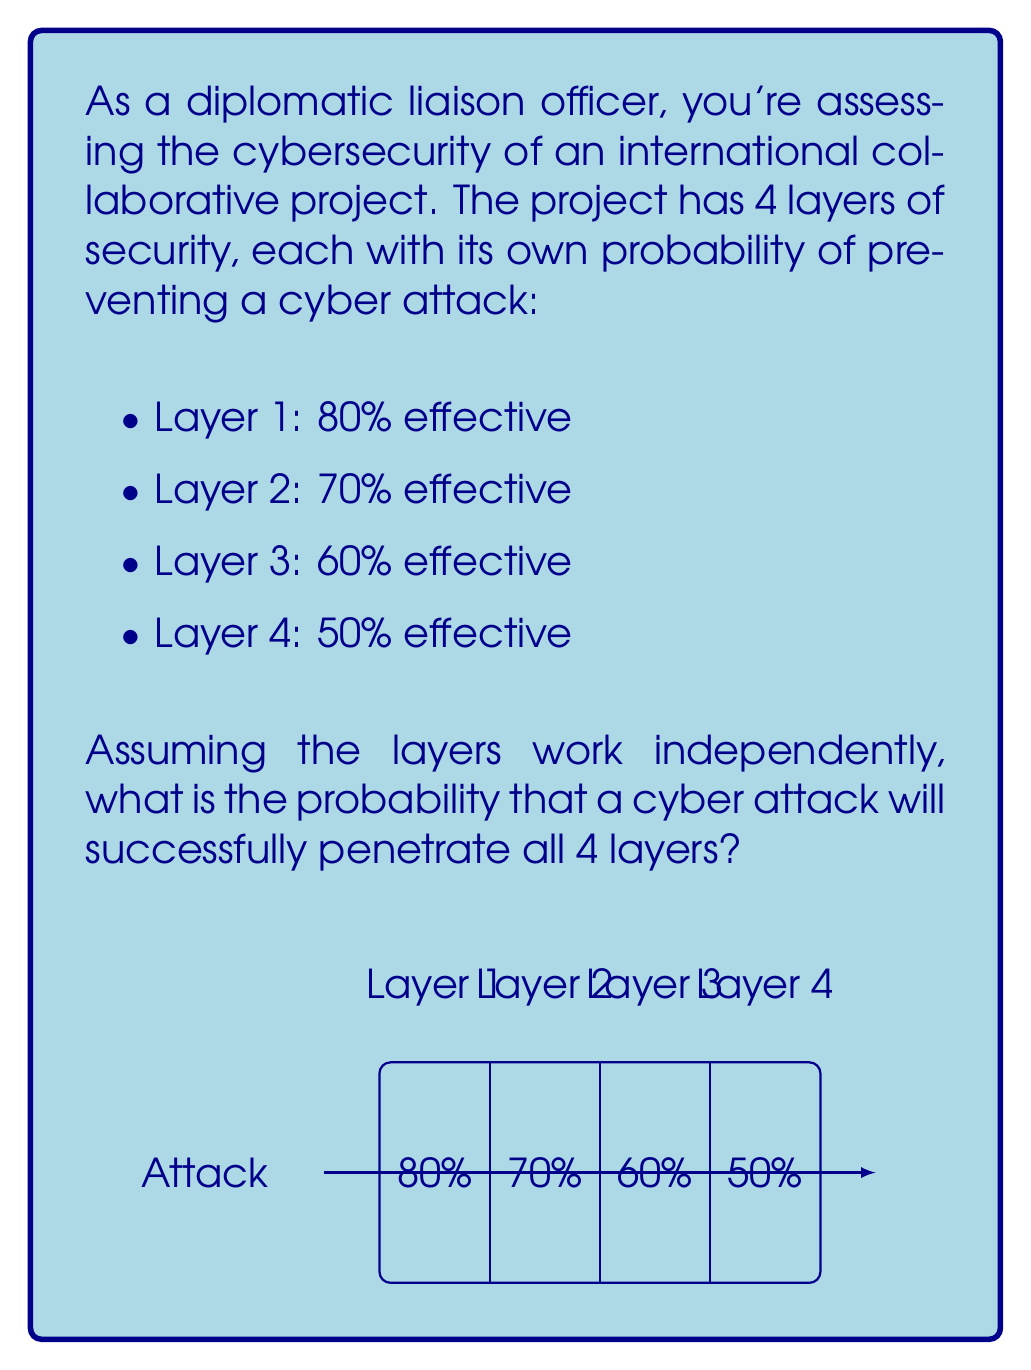Give your solution to this math problem. Let's approach this step-by-step:

1) First, we need to calculate the probability of an attack penetrating each layer:
   Layer 1: $1 - 0.80 = 0.20$ or 20%
   Layer 2: $1 - 0.70 = 0.30$ or 30%
   Layer 3: $1 - 0.60 = 0.40$ or 40%
   Layer 4: $1 - 0.50 = 0.50$ or 50%

2) For a successful attack, it needs to penetrate all layers. Since the layers work independently, we multiply these probabilities:

   $$P(\text{successful attack}) = 0.20 \times 0.30 \times 0.40 \times 0.50$$

3) Let's calculate this:
   $$P(\text{successful attack}) = 0.20 \times 0.30 \times 0.40 \times 0.50 = 0.012$$

4) Convert to percentage:
   $$0.012 \times 100\% = 1.2\%$$

Therefore, the probability of a cyber attack successfully penetrating all 4 layers is 1.2%.
Answer: 1.2% 